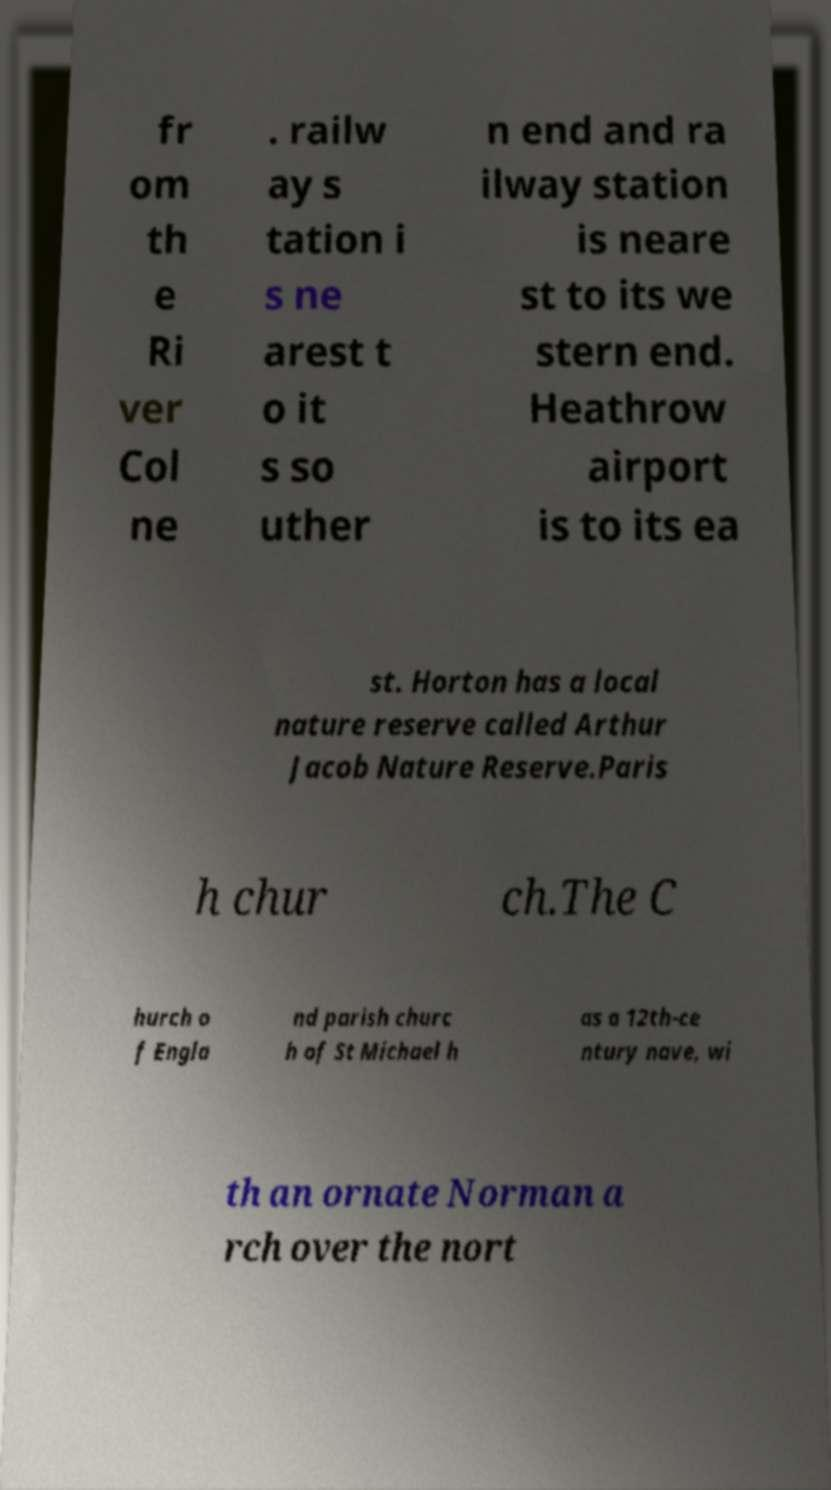Could you assist in decoding the text presented in this image and type it out clearly? fr om th e Ri ver Col ne . railw ay s tation i s ne arest t o it s so uther n end and ra ilway station is neare st to its we stern end. Heathrow airport is to its ea st. Horton has a local nature reserve called Arthur Jacob Nature Reserve.Paris h chur ch.The C hurch o f Engla nd parish churc h of St Michael h as a 12th-ce ntury nave, wi th an ornate Norman a rch over the nort 